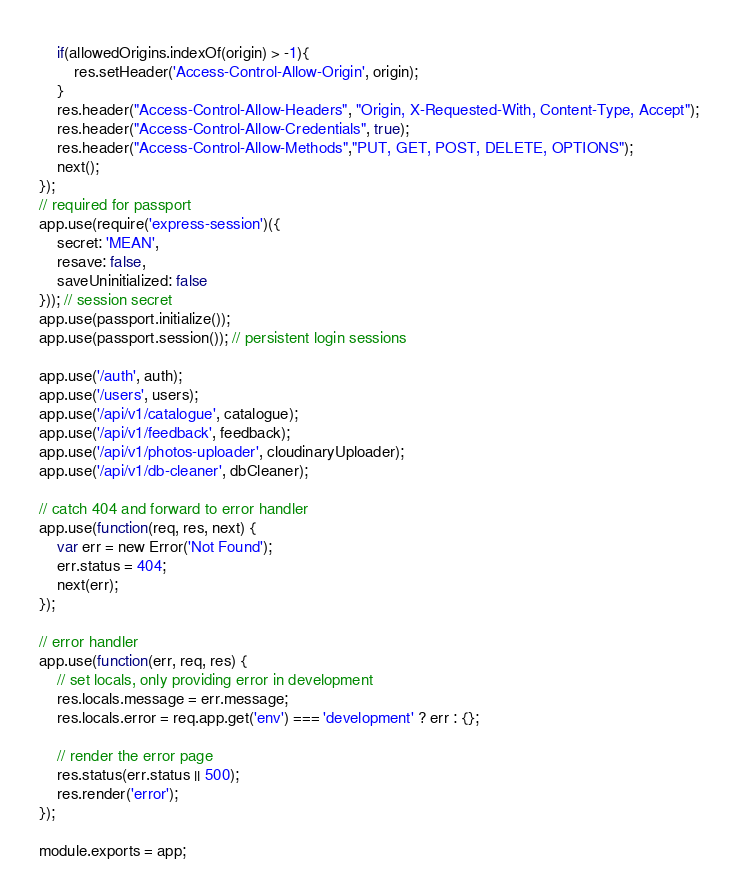Convert code to text. <code><loc_0><loc_0><loc_500><loc_500><_JavaScript_>    if(allowedOrigins.indexOf(origin) > -1){
        res.setHeader('Access-Control-Allow-Origin', origin);
    }
    res.header("Access-Control-Allow-Headers", "Origin, X-Requested-With, Content-Type, Accept");
    res.header("Access-Control-Allow-Credentials", true);
    res.header("Access-Control-Allow-Methods","PUT, GET, POST, DELETE, OPTIONS");
    next();
});
// required for passport
app.use(require('express-session')({
    secret: 'MEAN',
    resave: false,
    saveUninitialized: false
})); // session secret
app.use(passport.initialize());
app.use(passport.session()); // persistent login sessions

app.use('/auth', auth);
app.use('/users', users);
app.use('/api/v1/catalogue', catalogue);
app.use('/api/v1/feedback', feedback);
app.use('/api/v1/photos-uploader', cloudinaryUploader);
app.use('/api/v1/db-cleaner', dbCleaner);

// catch 404 and forward to error handler
app.use(function(req, res, next) {
    var err = new Error('Not Found');
    err.status = 404;
    next(err);
});

// error handler
app.use(function(err, req, res) {
    // set locals, only providing error in development
    res.locals.message = err.message;
    res.locals.error = req.app.get('env') === 'development' ? err : {};

    // render the error page
    res.status(err.status || 500);
    res.render('error');
});

module.exports = app;</code> 